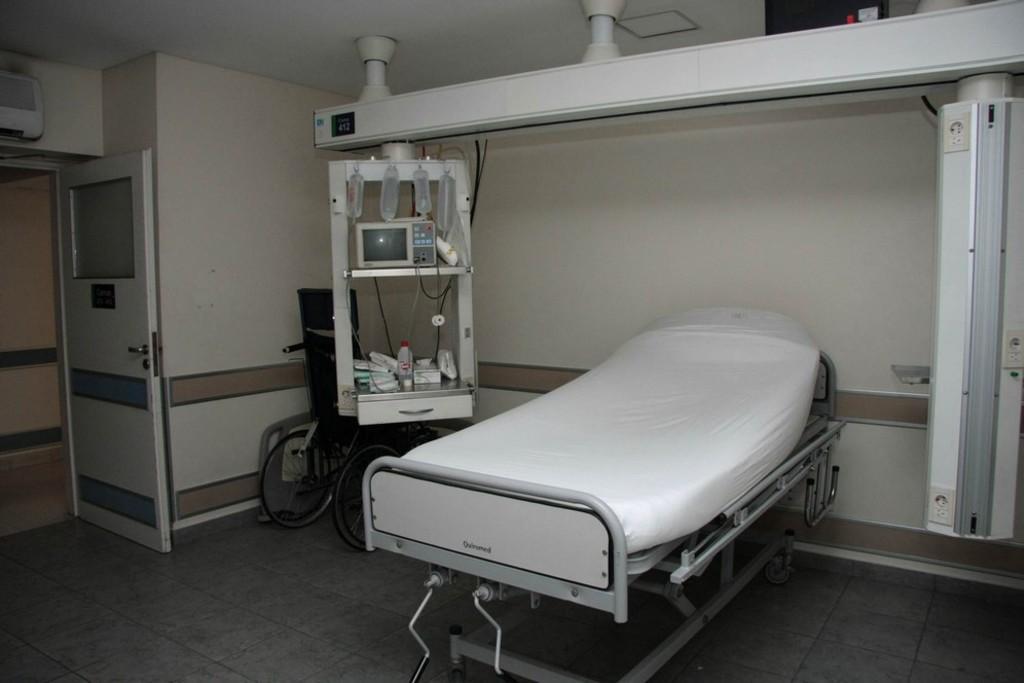Describe this image in one or two sentences. In this picture there is a bed, on which we can see bed-sheet. On the corner of the room we can see a wheelchair which is near to the machine. In this rack we can see screen, wires, bottles, plastic covers and other objects. On the left there is a door. 